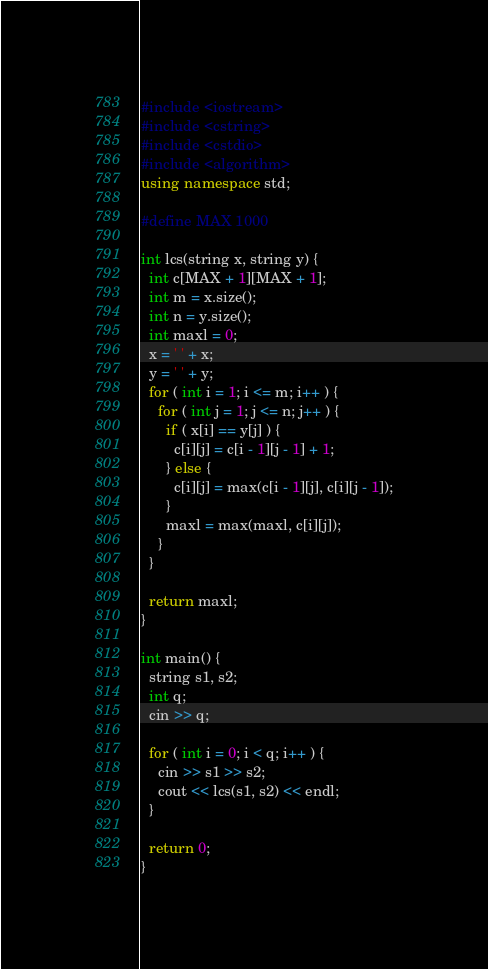Convert code to text. <code><loc_0><loc_0><loc_500><loc_500><_C++_>#include <iostream>
#include <cstring>
#include <cstdio>
#include <algorithm>
using namespace std;

#define MAX 1000

int lcs(string x, string y) {
  int c[MAX + 1][MAX + 1];
  int m = x.size();
  int n = y.size();
  int maxl = 0;
  x = ' ' + x;
  y = ' ' + y;
  for ( int i = 1; i <= m; i++ ) {
    for ( int j = 1; j <= n; j++ ) {
      if ( x[i] == y[j] ) {
        c[i][j] = c[i - 1][j - 1] + 1;
      } else {
        c[i][j] = max(c[i - 1][j], c[i][j - 1]);
      }
      maxl = max(maxl, c[i][j]);
    }
  }

  return maxl;
}

int main() {
  string s1, s2;
  int q;
  cin >> q;

  for ( int i = 0; i < q; i++ ) {
    cin >> s1 >> s2;
    cout << lcs(s1, s2) << endl;
  }

  return 0;
}</code> 